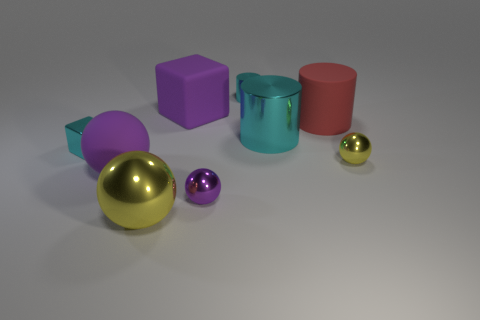Subtract all large yellow spheres. How many spheres are left? 3 Add 1 tiny cyan cubes. How many objects exist? 10 Subtract 1 cubes. How many cubes are left? 1 Subtract all purple cubes. How many cubes are left? 1 Subtract all balls. How many objects are left? 5 Subtract all purple cylinders. How many purple blocks are left? 1 Add 9 metallic cubes. How many metallic cubes are left? 10 Add 8 big red rubber cylinders. How many big red rubber cylinders exist? 9 Subtract 0 blue cylinders. How many objects are left? 9 Subtract all blue cubes. Subtract all blue balls. How many cubes are left? 2 